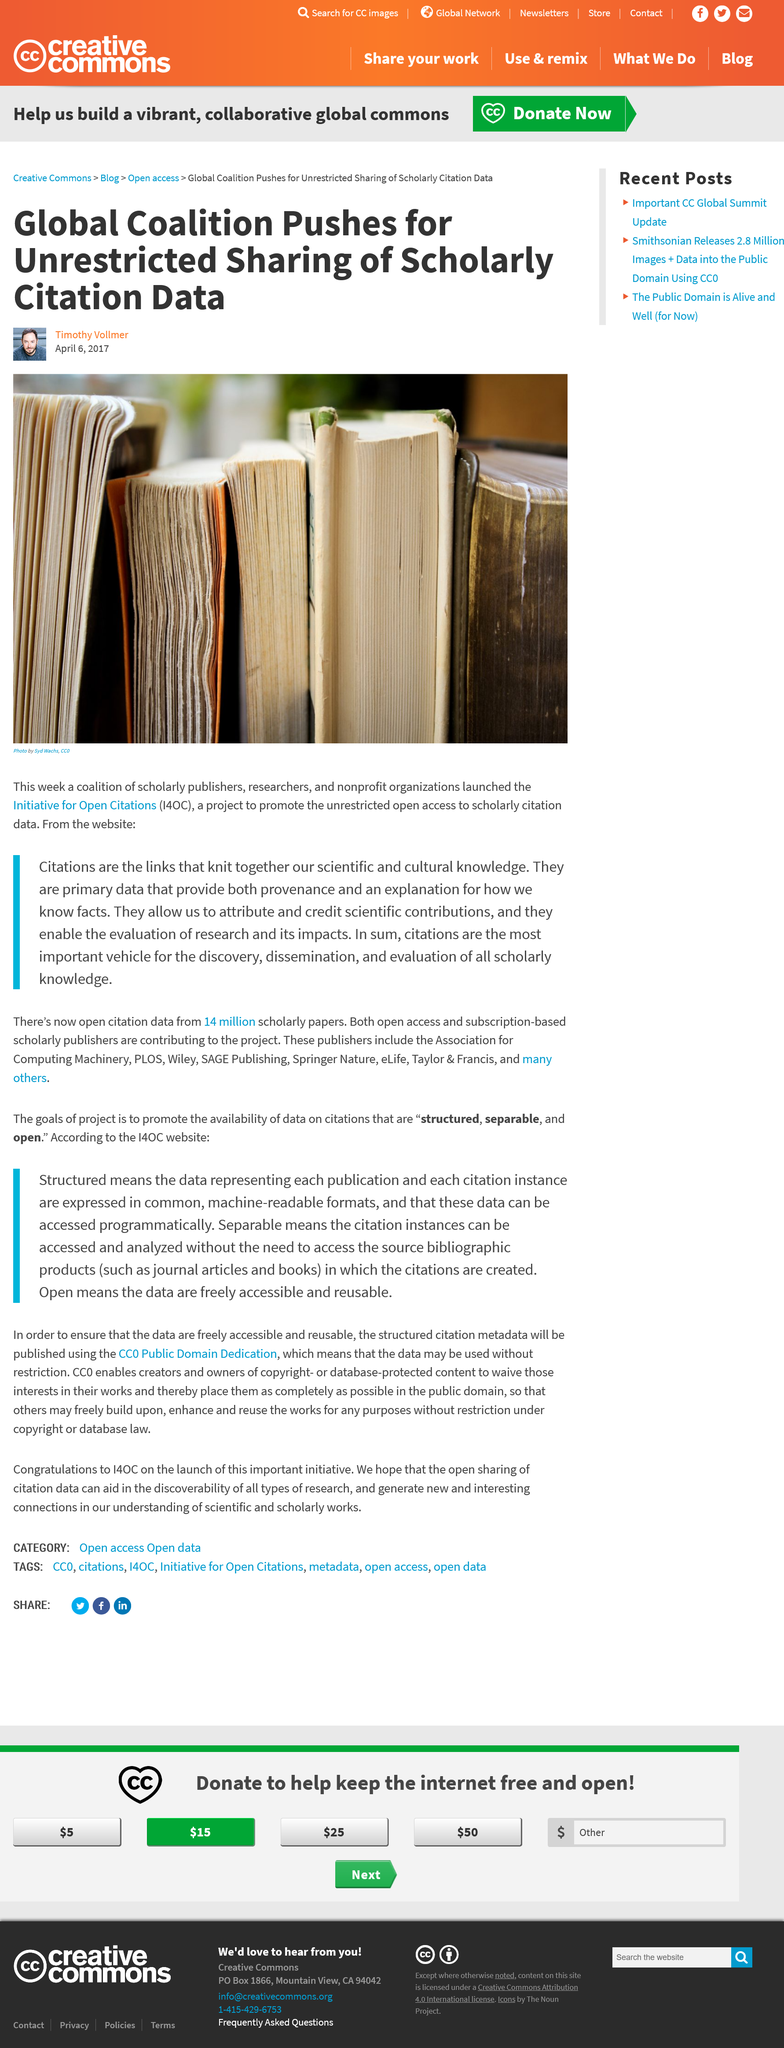Give some essential details in this illustration. The Initiative for Open Citations is a project aimed at promoting unrestricted access to scholarly citation data. The fact that primary data provides citations that provide provenance and explanation for how we know facts is a widely accepted truth. The Initiative for Open Citations is leading a global coalition that advocates for unrestricted access to scholarly citations. 